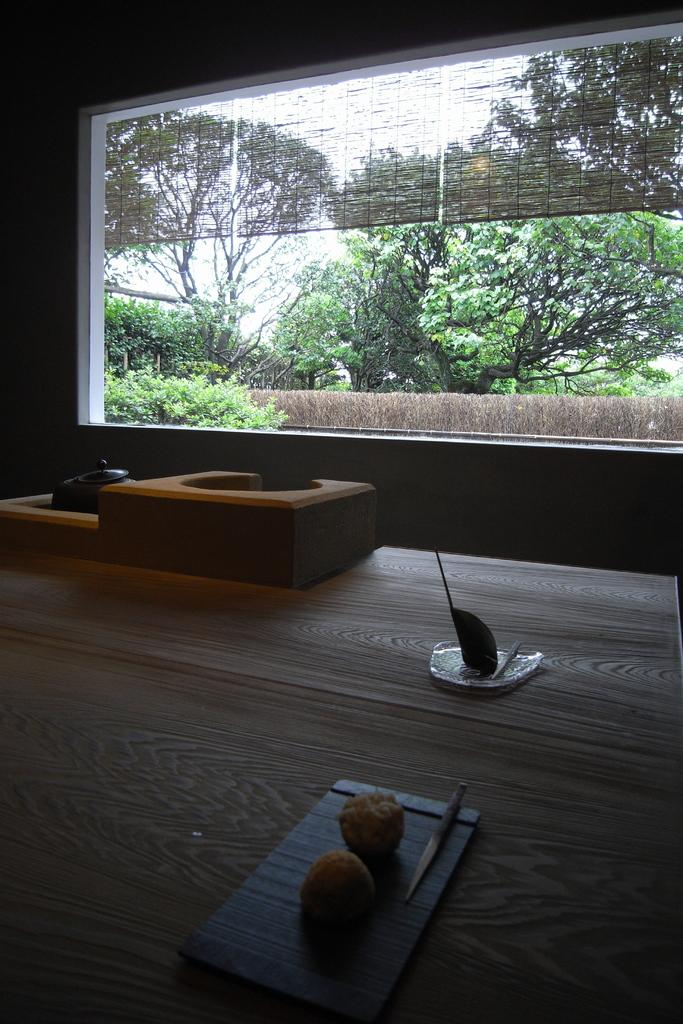What is on the serving plate in the image? There is food on the serving plate in the image. What type of container is present with a lid in the image? There is a bowl with a lid in the image. What reflective object is in the image? There is a mirror in the image. What type of window treatment is present in the image? Bamboo blinds are present in the image. What type of vegetation is visible in the image? Trees are visible in the image. What part of the natural environment is visible in the image? The sky is visible in the image. How many cakes are on the serving plate in the image? The provided facts do not mention cakes; there is only food on the serving plate. Is there a baby in the image? There is no mention of a baby in the provided facts, so we cannot confirm its presence in the image. 